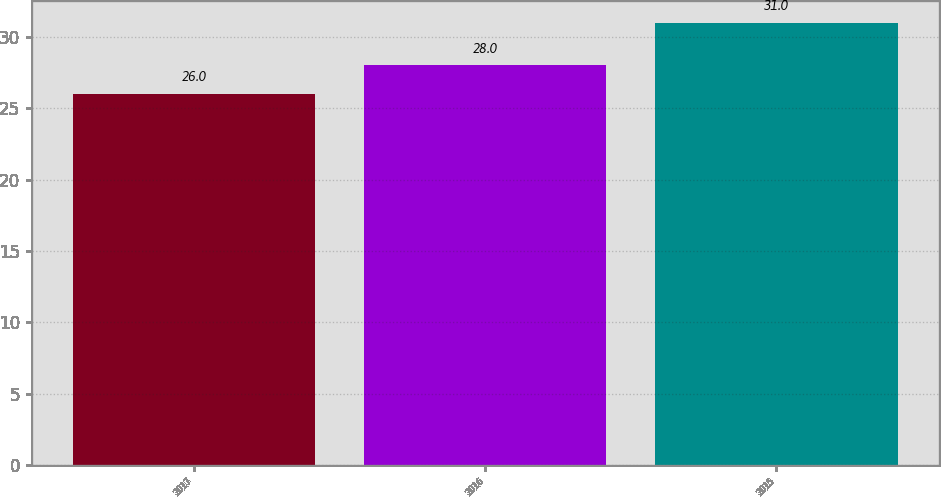Convert chart. <chart><loc_0><loc_0><loc_500><loc_500><bar_chart><fcel>2017<fcel>2016<fcel>2015<nl><fcel>26<fcel>28<fcel>31<nl></chart> 